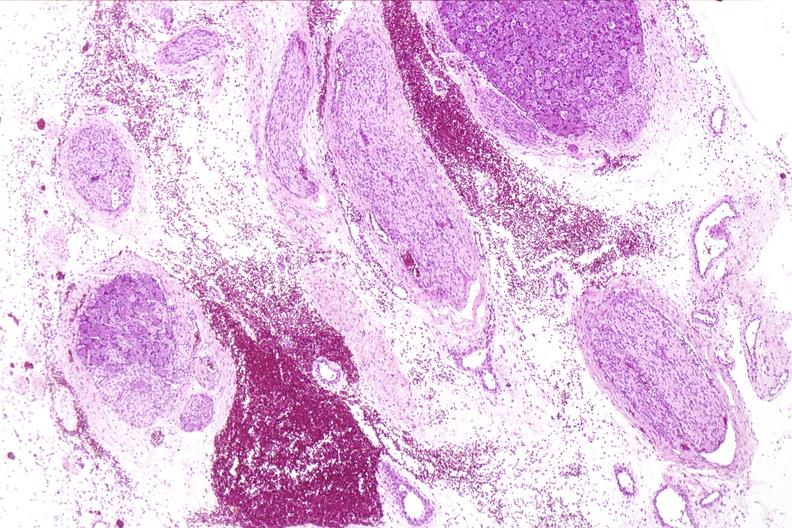s nervous present?
Answer the question using a single word or phrase. Yes 